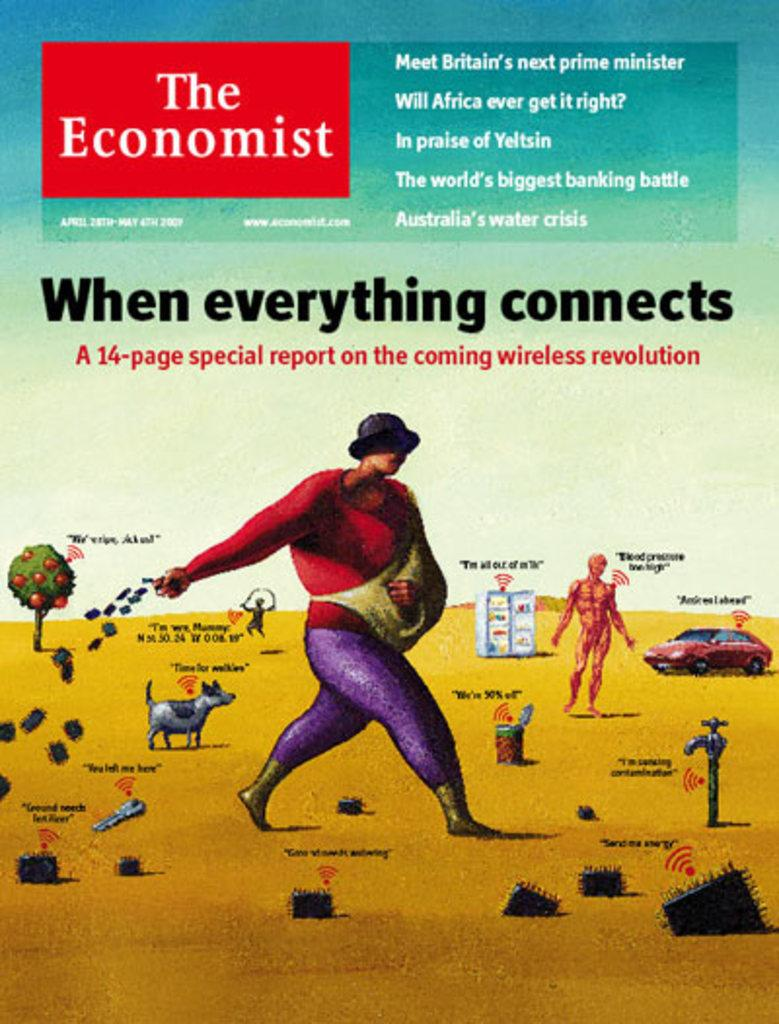<image>
Create a compact narrative representing the image presented. The economist poster that contains a fourteen page special report 